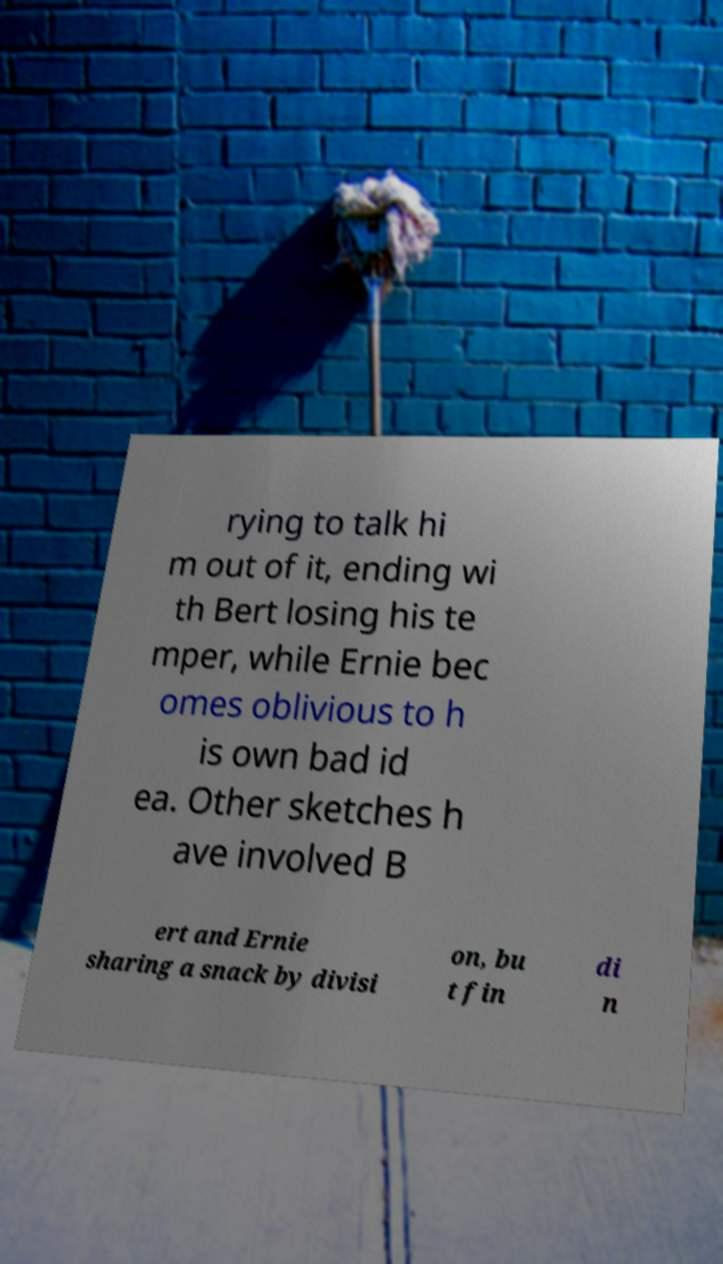There's text embedded in this image that I need extracted. Can you transcribe it verbatim? rying to talk hi m out of it, ending wi th Bert losing his te mper, while Ernie bec omes oblivious to h is own bad id ea. Other sketches h ave involved B ert and Ernie sharing a snack by divisi on, bu t fin di n 